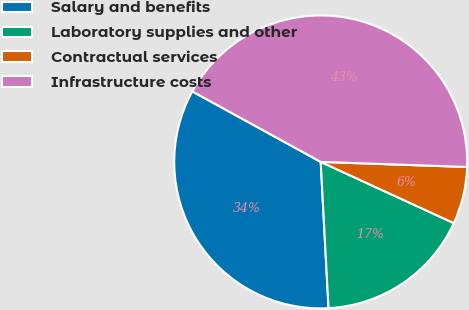Convert chart to OTSL. <chart><loc_0><loc_0><loc_500><loc_500><pie_chart><fcel>Salary and benefits<fcel>Laboratory supplies and other<fcel>Contractual services<fcel>Infrastructure costs<nl><fcel>33.84%<fcel>17.29%<fcel>6.31%<fcel>42.56%<nl></chart> 